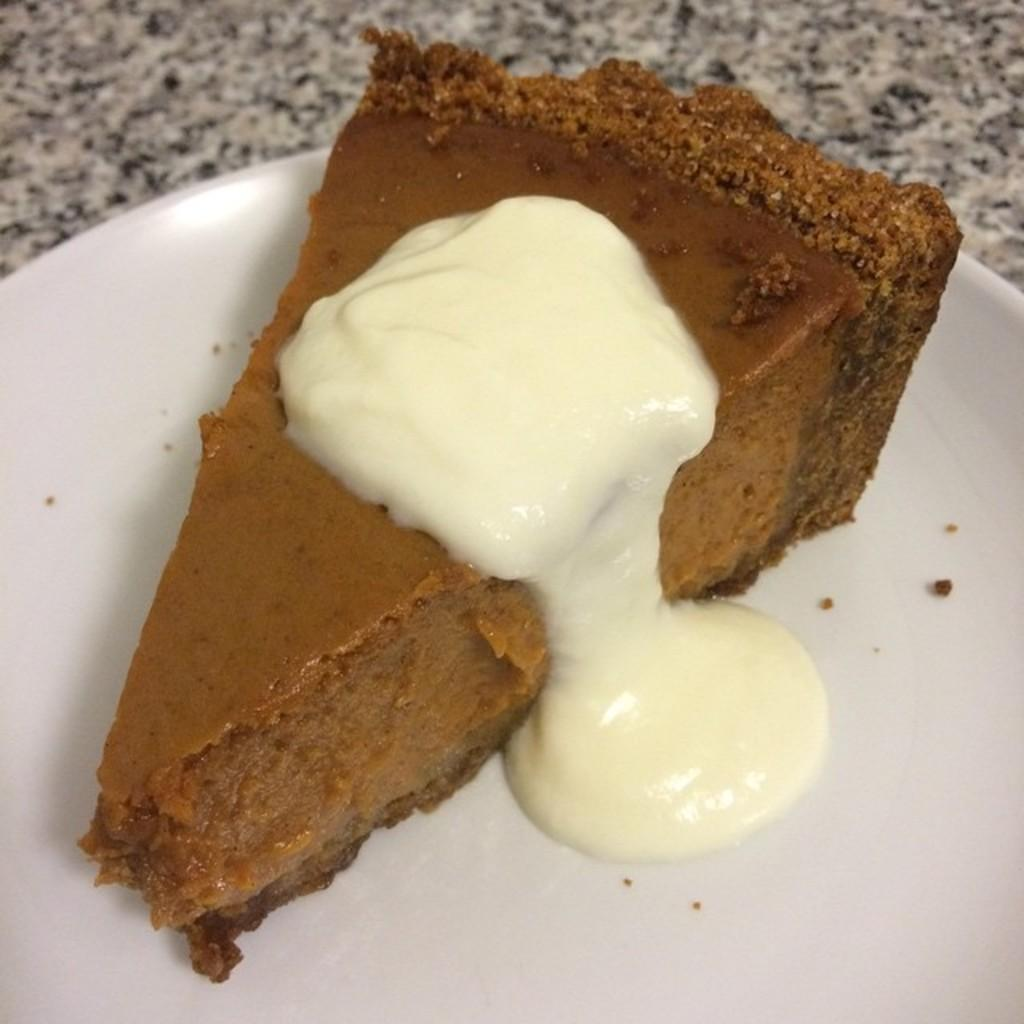What is on the surface in the image? There is a plate in the image. What is the plate placed on? The plate is on a surface. What is on the plate? There is cake in the plate. How does the cake receive approval from the spy in the image? There is no spy present in the image, and therefore no approval process for the cake. 